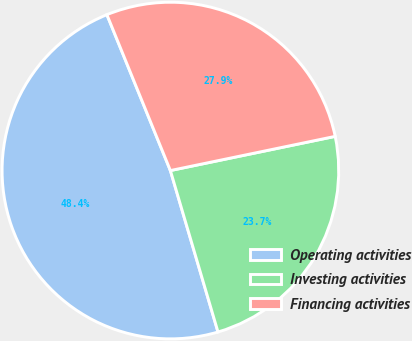<chart> <loc_0><loc_0><loc_500><loc_500><pie_chart><fcel>Operating activities<fcel>Investing activities<fcel>Financing activities<nl><fcel>48.41%<fcel>23.69%<fcel>27.9%<nl></chart> 